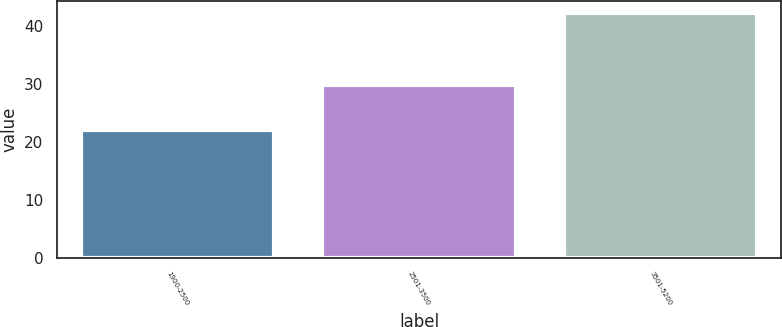<chart> <loc_0><loc_0><loc_500><loc_500><bar_chart><fcel>1900-2500<fcel>2501-3500<fcel>3501-5200<nl><fcel>22.05<fcel>29.87<fcel>42.27<nl></chart> 